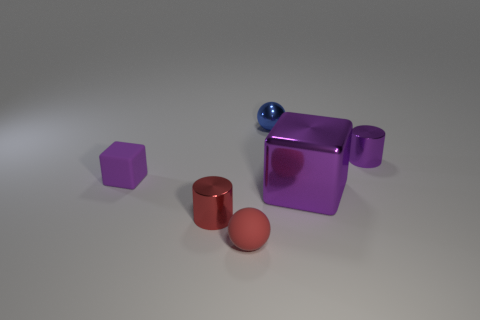Is there anything else that is the same size as the metallic block?
Provide a succinct answer. No. Is the ball that is in front of the matte cube made of the same material as the blue sphere?
Give a very brief answer. No. What number of purple things are either tiny metal balls or big metallic cubes?
Make the answer very short. 1. Is there a shiny cylinder that has the same color as the rubber ball?
Provide a succinct answer. Yes. Are there any big blocks made of the same material as the large thing?
Provide a succinct answer. No. There is a purple object that is both behind the large shiny cube and right of the tiny rubber ball; what is its shape?
Your answer should be compact. Cylinder. What number of big things are matte blocks or red rubber things?
Your answer should be compact. 0. What is the material of the small blue sphere?
Your response must be concise. Metal. What number of other things are there of the same shape as the red metal object?
Ensure brevity in your answer.  1. The shiny cube is what size?
Offer a terse response. Large. 